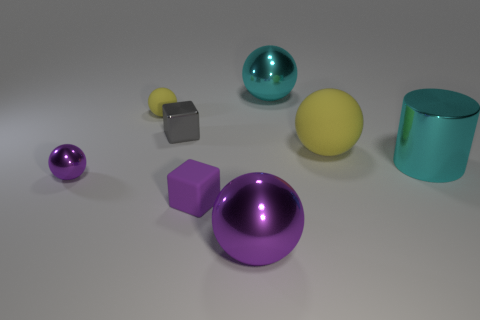How many other objects are there of the same size as the cyan metal sphere?
Ensure brevity in your answer.  3. Are there an equal number of tiny purple metallic things right of the tiny gray metal cube and cyan shiny cylinders?
Offer a terse response. No. What number of cylinders are the same material as the big cyan ball?
Your answer should be compact. 1. What color is the cube that is the same material as the big yellow sphere?
Make the answer very short. Purple. Is the shape of the tiny gray object the same as the large purple metallic object?
Offer a very short reply. No. There is a purple metal object to the left of the shiny thing in front of the small matte cube; are there any large shiny balls in front of it?
Keep it short and to the point. Yes. What number of small matte balls have the same color as the large matte ball?
Offer a terse response. 1. The purple rubber object that is the same size as the metallic cube is what shape?
Keep it short and to the point. Cube. There is a big yellow rubber sphere; are there any large objects to the right of it?
Keep it short and to the point. Yes. Is the cyan ball the same size as the purple rubber thing?
Keep it short and to the point. No. 